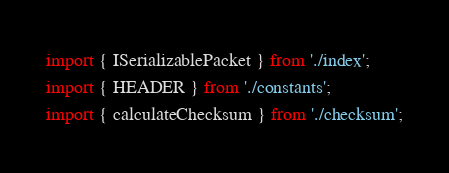Convert code to text. <code><loc_0><loc_0><loc_500><loc_500><_TypeScript_>import { ISerializablePacket } from './index';
import { HEADER } from './constants';
import { calculateChecksum } from './checksum';</code> 